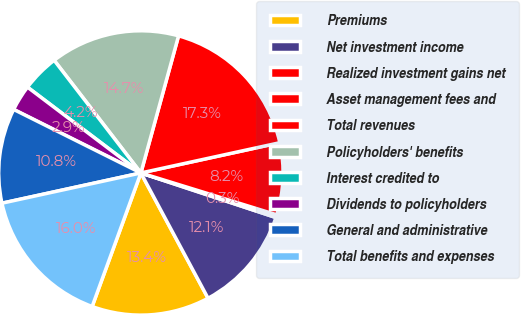<chart> <loc_0><loc_0><loc_500><loc_500><pie_chart><fcel>Premiums<fcel>Net investment income<fcel>Realized investment gains net<fcel>Asset management fees and<fcel>Total revenues<fcel>Policyholders' benefits<fcel>Interest credited to<fcel>Dividends to policyholders<fcel>General and administrative<fcel>Total benefits and expenses<nl><fcel>13.4%<fcel>12.09%<fcel>0.32%<fcel>8.17%<fcel>17.32%<fcel>14.71%<fcel>4.25%<fcel>2.94%<fcel>10.78%<fcel>16.02%<nl></chart> 